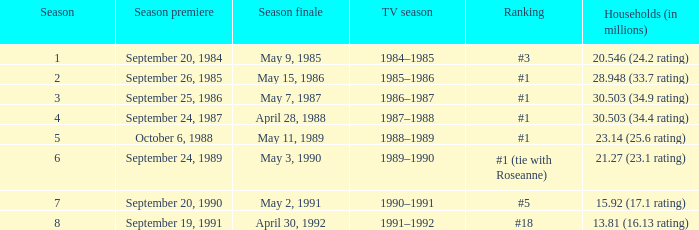Which tv season possesses a season below 8, and a household (in millions) of 1 1990–1991. Give me the full table as a dictionary. {'header': ['Season', 'Season premiere', 'Season finale', 'TV season', 'Ranking', 'Households (in millions)'], 'rows': [['1', 'September 20, 1984', 'May 9, 1985', '1984–1985', '#3', '20.546 (24.2 rating)'], ['2', 'September 26, 1985', 'May 15, 1986', '1985–1986', '#1', '28.948 (33.7 rating)'], ['3', 'September 25, 1986', 'May 7, 1987', '1986–1987', '#1', '30.503 (34.9 rating)'], ['4', 'September 24, 1987', 'April 28, 1988', '1987–1988', '#1', '30.503 (34.4 rating)'], ['5', 'October 6, 1988', 'May 11, 1989', '1988–1989', '#1', '23.14 (25.6 rating)'], ['6', 'September 24, 1989', 'May 3, 1990', '1989–1990', '#1 (tie with Roseanne)', '21.27 (23.1 rating)'], ['7', 'September 20, 1990', 'May 2, 1991', '1990–1991', '#5', '15.92 (17.1 rating)'], ['8', 'September 19, 1991', 'April 30, 1992', '1991–1992', '#18', '13.81 (16.13 rating)']]} 